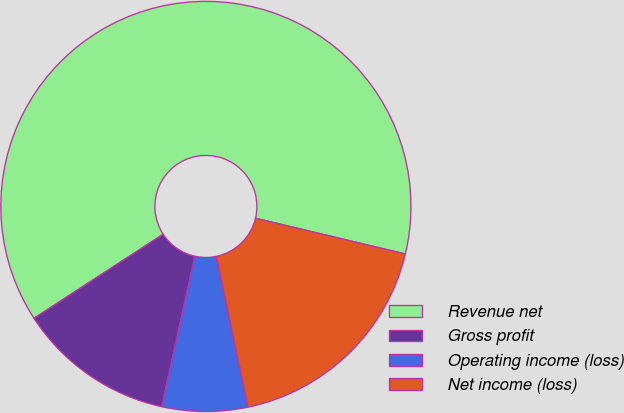Convert chart. <chart><loc_0><loc_0><loc_500><loc_500><pie_chart><fcel>Revenue net � � � � � � � � �<fcel>Gross profit � � � � � � � � �<fcel>Operating income (loss) � � �<fcel>Net income (loss) � � � � � �<nl><fcel>62.91%<fcel>12.36%<fcel>6.75%<fcel>17.98%<nl></chart> 